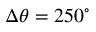<formula> <loc_0><loc_0><loc_500><loc_500>\Delta \theta = 2 5 0 ^ { \circ }</formula> 